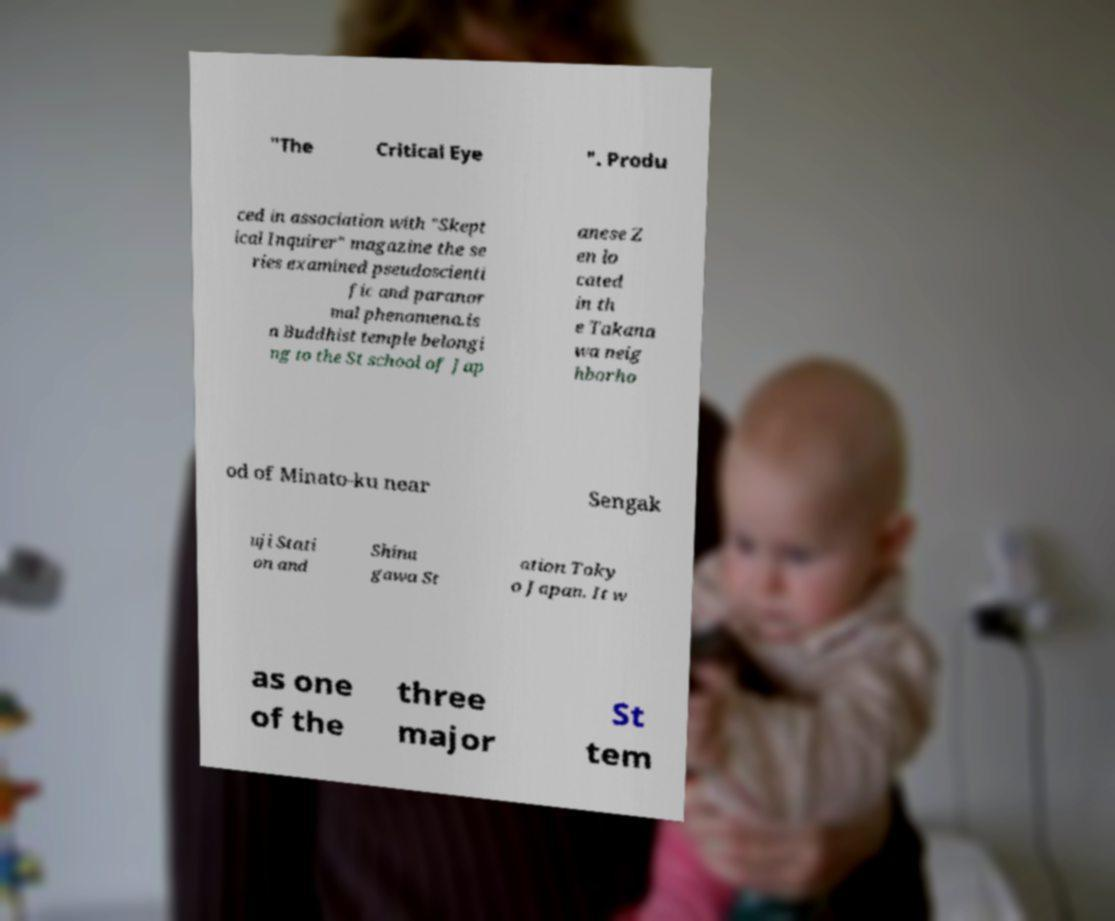There's text embedded in this image that I need extracted. Can you transcribe it verbatim? "The Critical Eye ". Produ ced in association with "Skept ical Inquirer" magazine the se ries examined pseudoscienti fic and paranor mal phenomena.is a Buddhist temple belongi ng to the St school of Jap anese Z en lo cated in th e Takana wa neig hborho od of Minato-ku near Sengak uji Stati on and Shina gawa St ation Toky o Japan. It w as one of the three major St tem 